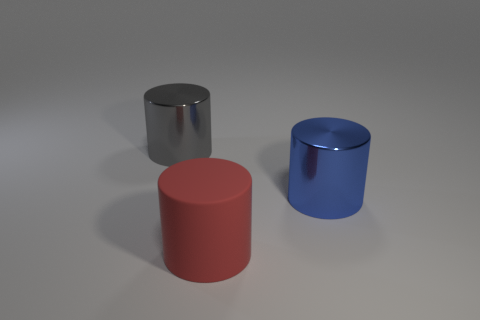Add 3 large blue metal cylinders. How many objects exist? 6 Subtract 0 red balls. How many objects are left? 3 Subtract all large gray things. Subtract all tiny red matte cylinders. How many objects are left? 2 Add 1 big things. How many big things are left? 4 Add 1 big red rubber cylinders. How many big red rubber cylinders exist? 2 